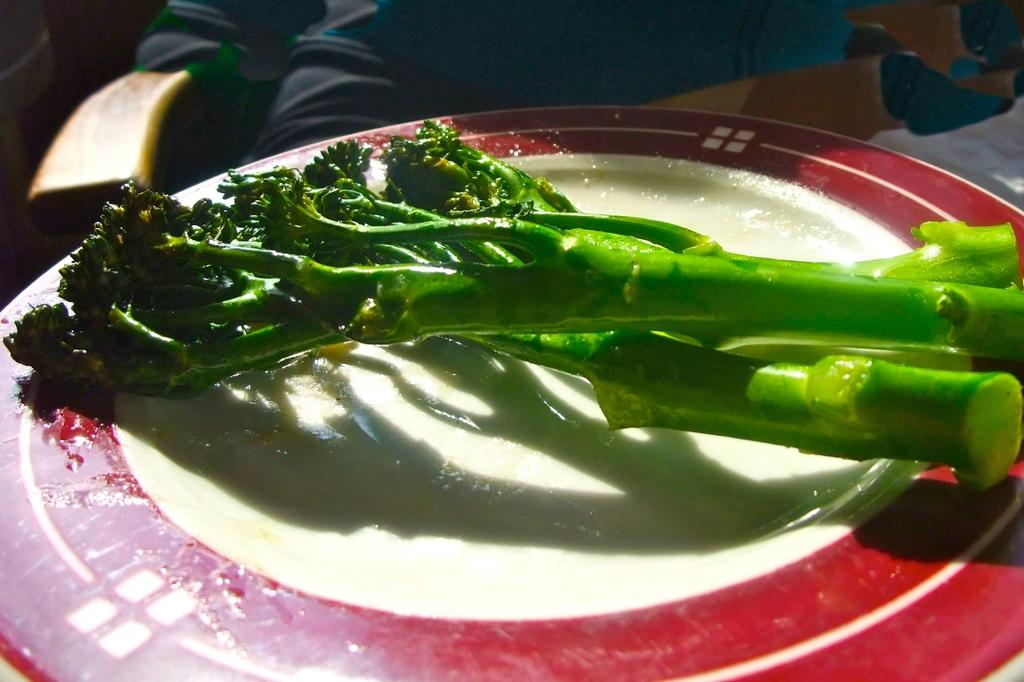What object is present on the left side of the image? There is a handle on the left side of the image. What is on the plate in the image? The plate has green colored stems on it. Can you describe the background of the image? The background of the image is blurry. What type of hair can be seen on the farmer in the image? There is no farmer or hair present in the image. Is the rain visible in the image? There is no rain visible in the image. 